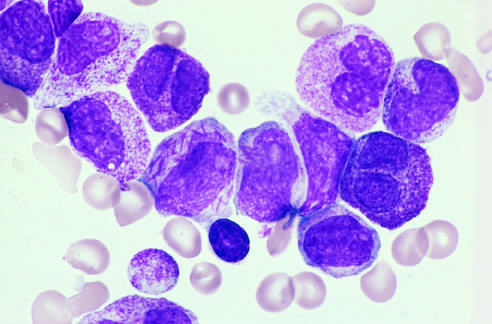do other characteristic findings include a cell in the center of the field with multiple needlelike auer rods?
Answer the question using a single word or phrase. Yes 